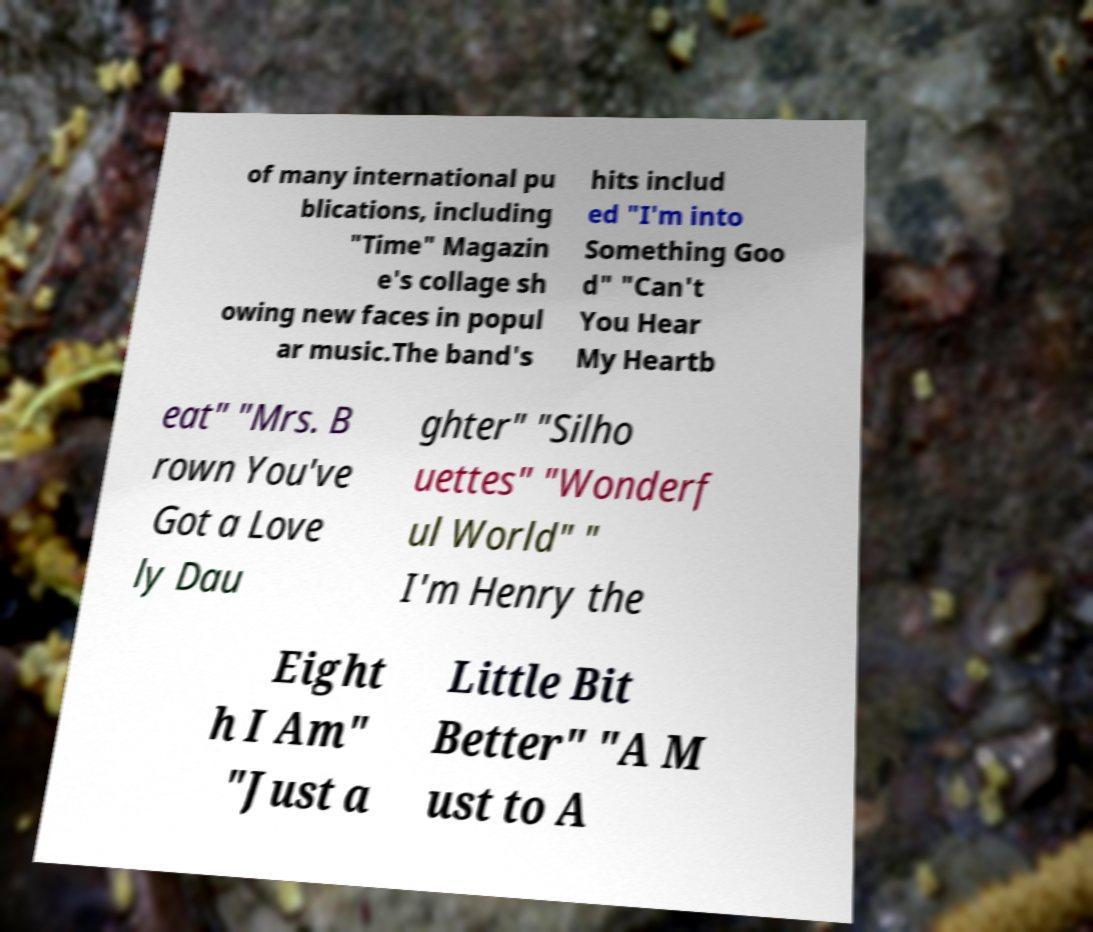Can you accurately transcribe the text from the provided image for me? of many international pu blications, including "Time" Magazin e's collage sh owing new faces in popul ar music.The band's hits includ ed "I'm into Something Goo d" "Can't You Hear My Heartb eat" "Mrs. B rown You've Got a Love ly Dau ghter" "Silho uettes" "Wonderf ul World" " I'm Henry the Eight h I Am" "Just a Little Bit Better" "A M ust to A 